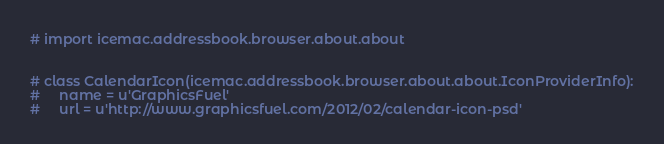<code> <loc_0><loc_0><loc_500><loc_500><_Python_># import icemac.addressbook.browser.about.about


# class CalendarIcon(icemac.addressbook.browser.about.about.IconProviderInfo):
#     name = u'GraphicsFuel'
#     url = u'http://www.graphicsfuel.com/2012/02/calendar-icon-psd'
</code> 